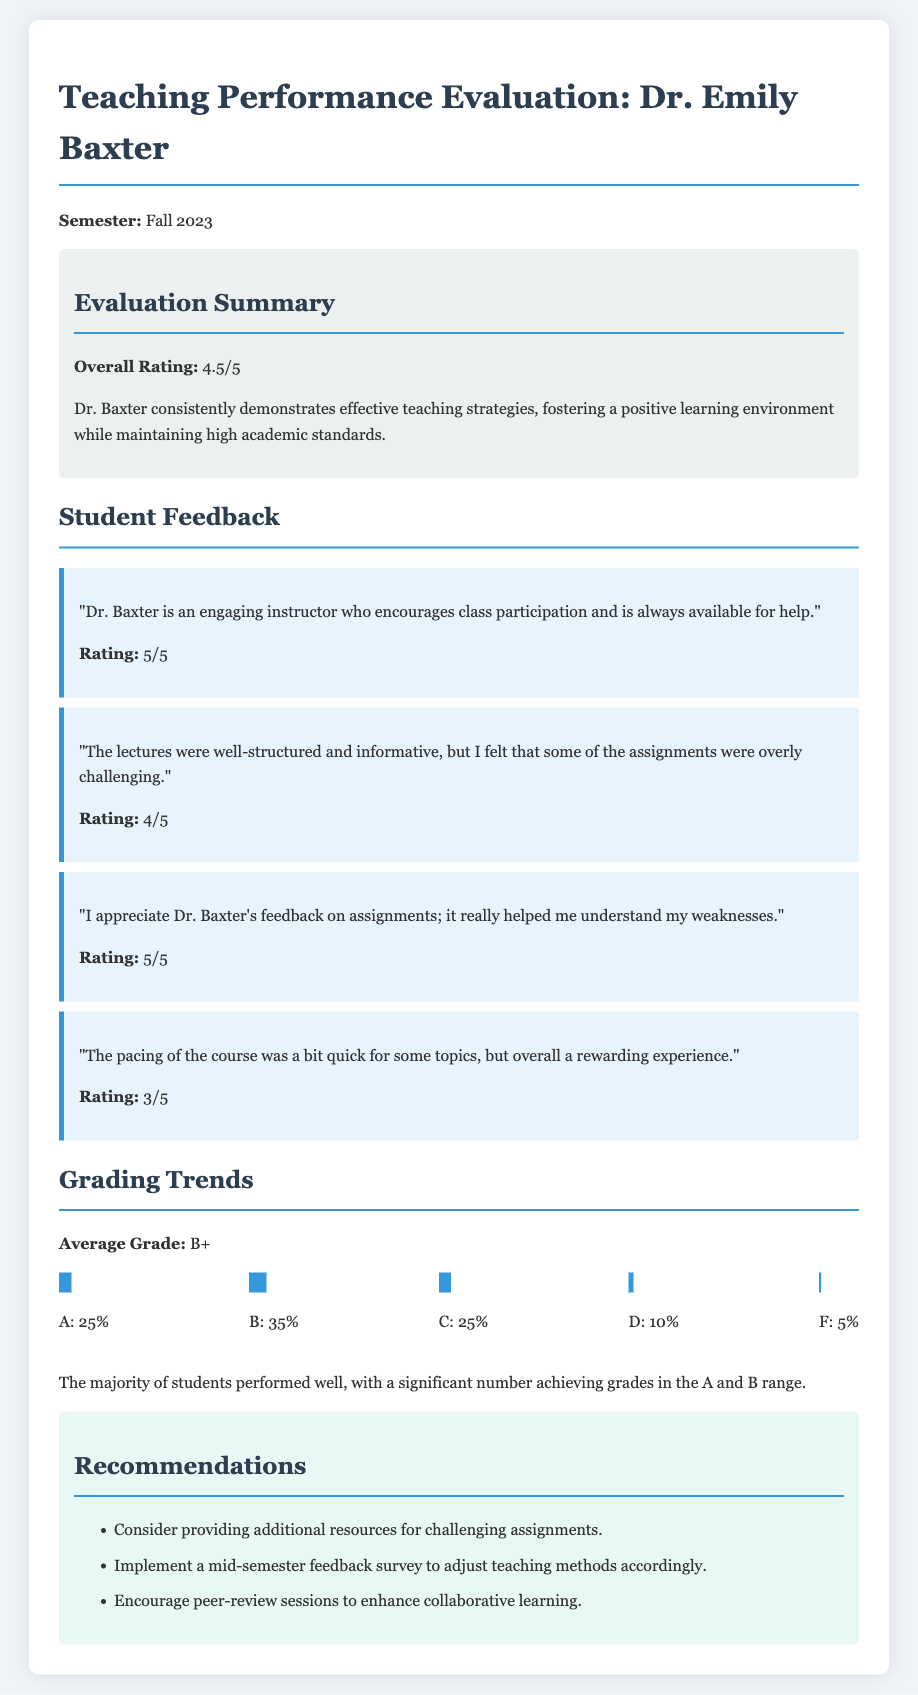What is Dr. Baxter's overall rating? The overall rating is mentioned in the evaluation summary section of the document.
Answer: 4.5/5 What was the average grade in the class? The average grade is stated clearly in the grading trends section of the document.
Answer: B+ What percentage of students received an A? The grade distribution chart specifies the percentage of students achieving various grades.
Answer: 25% What feedback did a student give regarding assignment feedback? A specific feedback item highlights the student's appreciation for the feedback on assignments in the student feedback section.
Answer: "I appreciate Dr. Baxter's feedback on assignments; it really helped me understand my weaknesses." What is one of the recommendations made for Dr. Baxter? The recommendations section lists suggestions for improving teaching effectiveness.
Answer: Provide additional resources for challenging assignments 